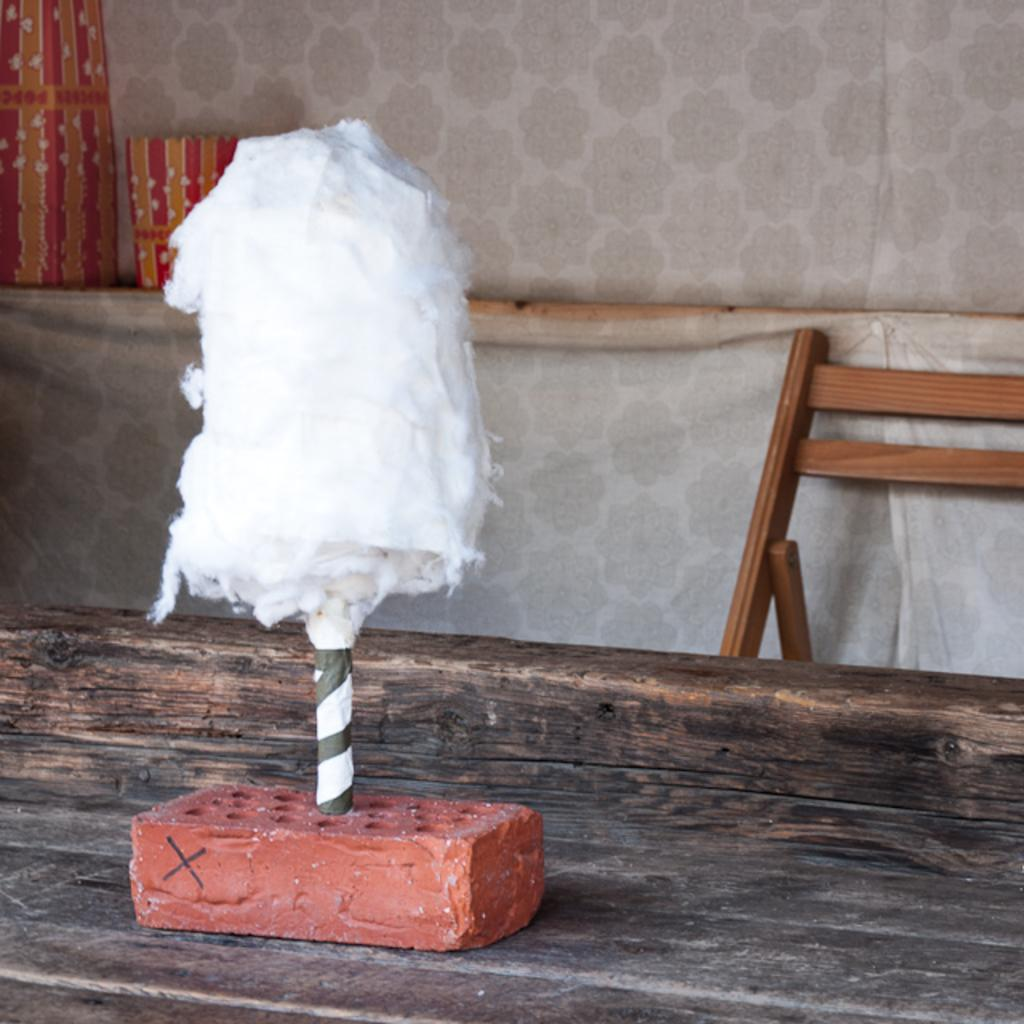What is the main subject of the image? The main subject of the image is a pole with cotton inserted in a brick. What can be seen in the background of the image? There is a chair and a wall visible in the background of the image. What is located at the bottom of the image? There is a table at the bottom of the image. What verse is being recited by the person in the image? There is no person present in the image, and therefore no verse being recited. 